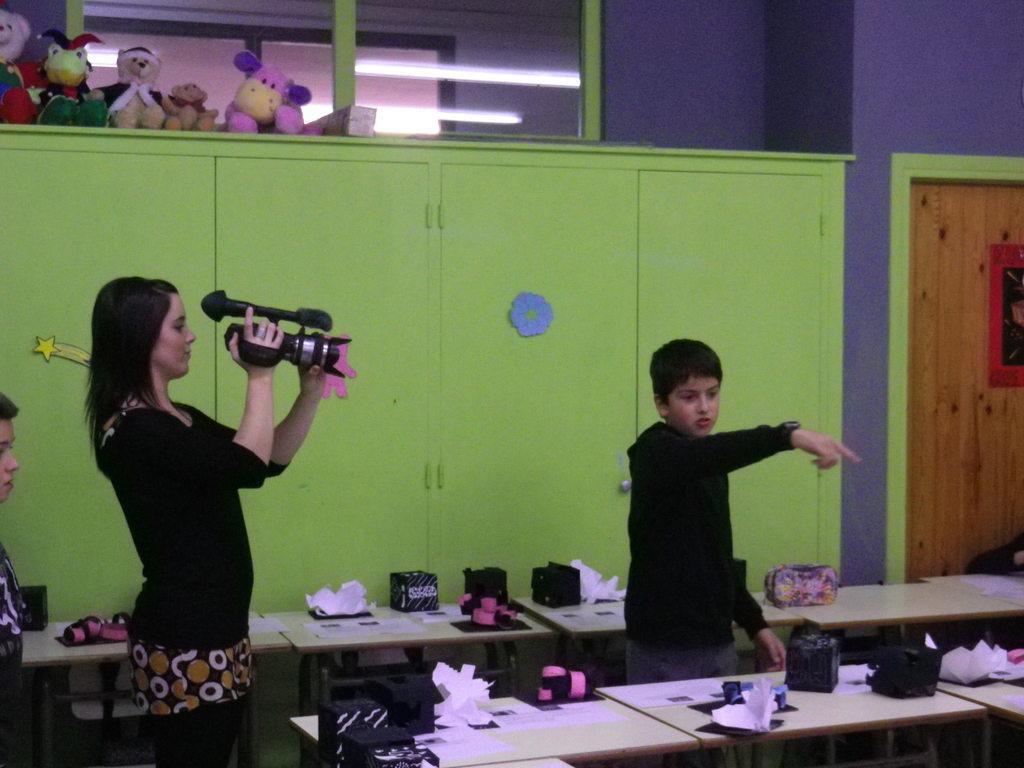Please provide a concise description of this image. In this image I can see two persons standing. The person at right wearing black dress, the person at left wearing black shirt holding camera. Background I can see cupboards in green color and wall in purple color. 